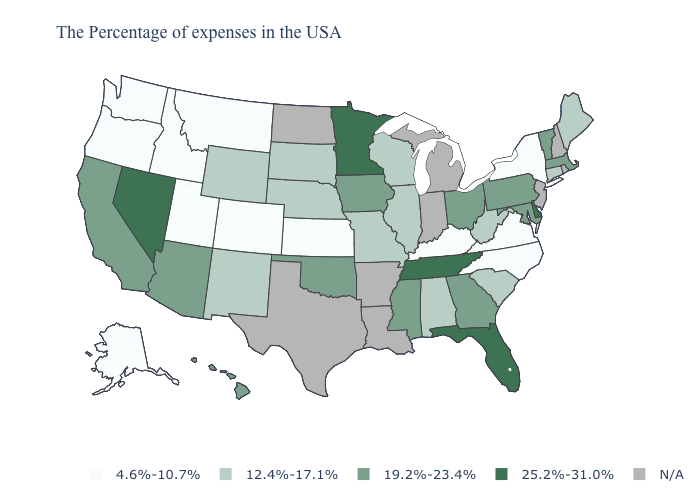What is the value of Pennsylvania?
Concise answer only. 19.2%-23.4%. Which states have the highest value in the USA?
Quick response, please. Delaware, Florida, Tennessee, Minnesota, Nevada. Name the states that have a value in the range 4.6%-10.7%?
Answer briefly. New York, Virginia, North Carolina, Kentucky, Kansas, Colorado, Utah, Montana, Idaho, Washington, Oregon, Alaska. What is the lowest value in the MidWest?
Short answer required. 4.6%-10.7%. Name the states that have a value in the range 4.6%-10.7%?
Concise answer only. New York, Virginia, North Carolina, Kentucky, Kansas, Colorado, Utah, Montana, Idaho, Washington, Oregon, Alaska. What is the highest value in the USA?
Keep it brief. 25.2%-31.0%. Name the states that have a value in the range N/A?
Quick response, please. Rhode Island, New Hampshire, New Jersey, Michigan, Indiana, Louisiana, Arkansas, Texas, North Dakota. Does Delaware have the lowest value in the South?
Write a very short answer. No. Among the states that border Missouri , which have the lowest value?
Write a very short answer. Kentucky, Kansas. How many symbols are there in the legend?
Short answer required. 5. Does Kansas have the lowest value in the USA?
Give a very brief answer. Yes. What is the value of Georgia?
Be succinct. 19.2%-23.4%. Does the map have missing data?
Short answer required. Yes. 